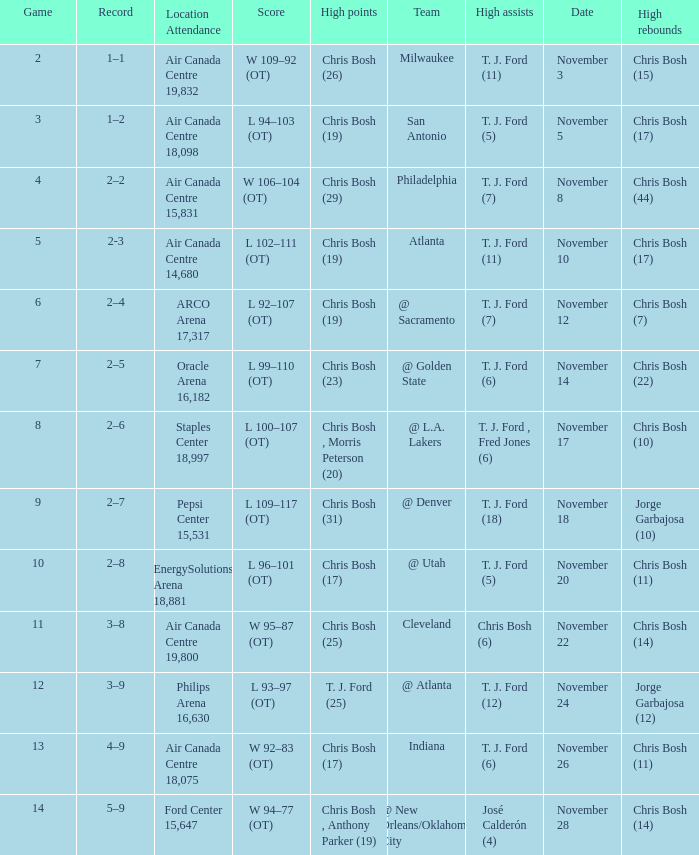Help me parse the entirety of this table. {'header': ['Game', 'Record', 'Location Attendance', 'Score', 'High points', 'Team', 'High assists', 'Date', 'High rebounds'], 'rows': [['2', '1–1', 'Air Canada Centre 19,832', 'W 109–92 (OT)', 'Chris Bosh (26)', 'Milwaukee', 'T. J. Ford (11)', 'November 3', 'Chris Bosh (15)'], ['3', '1–2', 'Air Canada Centre 18,098', 'L 94–103 (OT)', 'Chris Bosh (19)', 'San Antonio', 'T. J. Ford (5)', 'November 5', 'Chris Bosh (17)'], ['4', '2–2', 'Air Canada Centre 15,831', 'W 106–104 (OT)', 'Chris Bosh (29)', 'Philadelphia', 'T. J. Ford (7)', 'November 8', 'Chris Bosh (44)'], ['5', '2-3', 'Air Canada Centre 14,680', 'L 102–111 (OT)', 'Chris Bosh (19)', 'Atlanta', 'T. J. Ford (11)', 'November 10', 'Chris Bosh (17)'], ['6', '2–4', 'ARCO Arena 17,317', 'L 92–107 (OT)', 'Chris Bosh (19)', '@ Sacramento', 'T. J. Ford (7)', 'November 12', 'Chris Bosh (7)'], ['7', '2–5', 'Oracle Arena 16,182', 'L 99–110 (OT)', 'Chris Bosh (23)', '@ Golden State', 'T. J. Ford (6)', 'November 14', 'Chris Bosh (22)'], ['8', '2–6', 'Staples Center 18,997', 'L 100–107 (OT)', 'Chris Bosh , Morris Peterson (20)', '@ L.A. Lakers', 'T. J. Ford , Fred Jones (6)', 'November 17', 'Chris Bosh (10)'], ['9', '2–7', 'Pepsi Center 15,531', 'L 109–117 (OT)', 'Chris Bosh (31)', '@ Denver', 'T. J. Ford (18)', 'November 18', 'Jorge Garbajosa (10)'], ['10', '2–8', 'EnergySolutions Arena 18,881', 'L 96–101 (OT)', 'Chris Bosh (17)', '@ Utah', 'T. J. Ford (5)', 'November 20', 'Chris Bosh (11)'], ['11', '3–8', 'Air Canada Centre 19,800', 'W 95–87 (OT)', 'Chris Bosh (25)', 'Cleveland', 'Chris Bosh (6)', 'November 22', 'Chris Bosh (14)'], ['12', '3–9', 'Philips Arena 16,630', 'L 93–97 (OT)', 'T. J. Ford (25)', '@ Atlanta', 'T. J. Ford (12)', 'November 24', 'Jorge Garbajosa (12)'], ['13', '4–9', 'Air Canada Centre 18,075', 'W 92–83 (OT)', 'Chris Bosh (17)', 'Indiana', 'T. J. Ford (6)', 'November 26', 'Chris Bosh (11)'], ['14', '5–9', 'Ford Center 15,647', 'W 94–77 (OT)', 'Chris Bosh , Anthony Parker (19)', '@ New Orleans/Oklahoma City', 'José Calderón (4)', 'November 28', 'Chris Bosh (14)']]} Who had high assists when they played against San Antonio? T. J. Ford (5). 